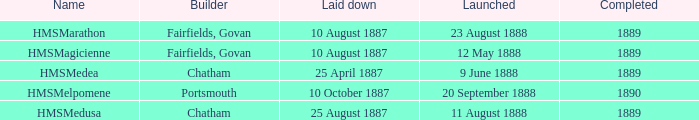On april 25, 1887, what ship began its construction? HMSMedea. 